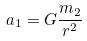Convert formula to latex. <formula><loc_0><loc_0><loc_500><loc_500>a _ { 1 } = G \frac { m _ { 2 } } { r ^ { 2 } }</formula> 